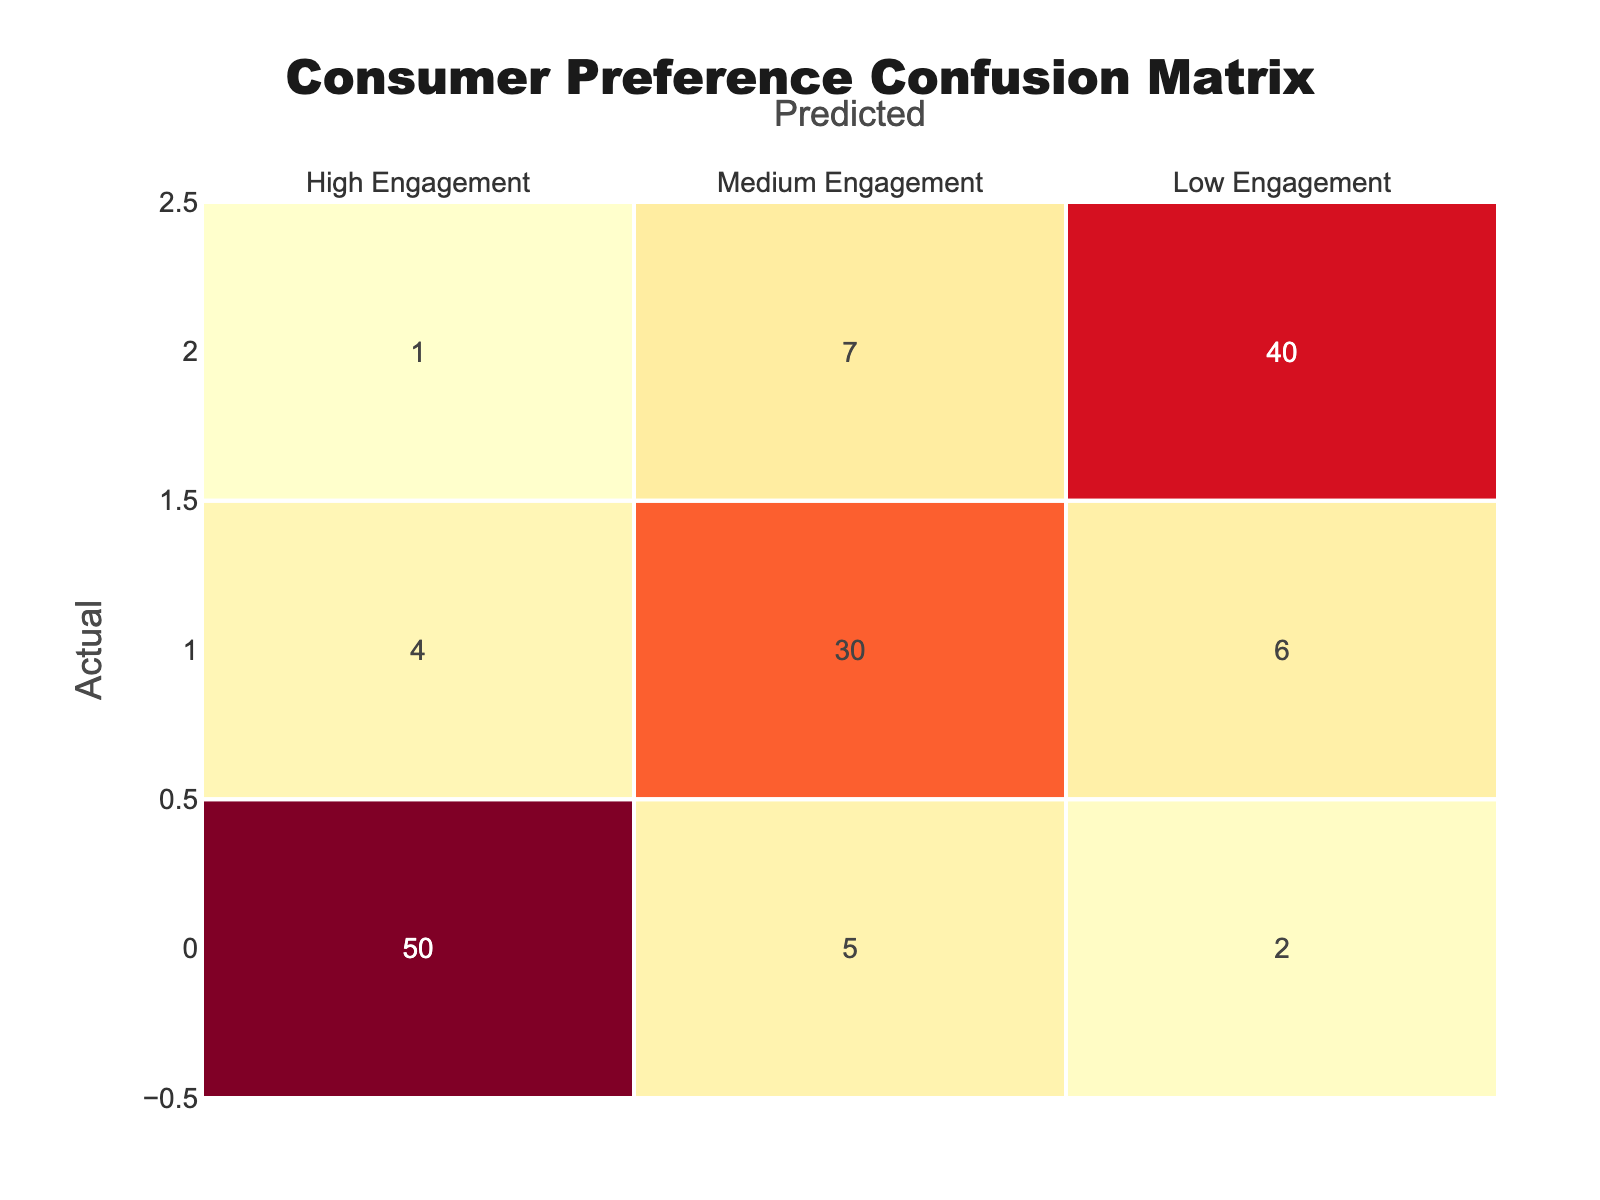What is the count of true positives for high engagement? The true positives for a category are found on the diagonal of the confusion matrix. For high engagement, this is represented in the cell where the actual engagement is high engagement and the predicted engagement is also high engagement. Referring to the table, the count is 50.
Answer: 50 What is the total count of medium engagement predictions? To find the total count of medium engagement predictions, add the predictions from the medium engagement row: 4 (low engagement predicted as medium) + 30 (medium engagement predicted as medium) + 6 (high engagement predicted as medium) = 40.
Answer: 40 Is there more misclassification in the low engagement category than in the high engagement category? Misclassification for each category is calculated by summing the off-diagonal values. For low engagement, the misclassifications are 1 (predicted high) + 7 (predicted medium) = 8. For high engagement, the misclassifications are 5 (predicted medium) + 2 (predicted low) = 7. Since 8 is greater than 7, the statement is true.
Answer: Yes What is the overall accuracy of the predictions? To calculate overall accuracy, we use the formula: (True Positives) / (Total Predictions). Here, the true positives are the sum of the diagonal elements (50 + 30 + 40 = 120). The total predictions are the sum of all elements in the table (50 + 5 + 2 + 4 + 30 + 6 + 1 + 7 + 40 = 145). Accuracy = 120 / 145 ≈ 0.827.
Answer: Approximately 0.827 What is the percentage of high engagement that was correctly predicted? To find the percentage of high engagement that was correctly predicted, divide the true positives for high engagement (50) by the total actual high engagement cases (50 + 5 + 2 = 57). Calculate the percentage: (50 / 57) * 100 ≈ 87.72%.
Answer: Approximately 87.72% What is the difference in the number of misclassifications between medium engagement and low engagement? First, calculate misclassifications for medium engagement: 4 (predicted high) + 6 (predicted low) = 10. For low engagement, misclassifications are 1 (predicted high) + 7 (predicted medium) = 8. The difference is 10 - 8 = 2.
Answer: 2 Which engagement level has the highest true positive count? By examining the diagonal, the counts are 50 for high engagement, 30 for medium engagement, and 40 for low engagement. Since 50 is greater than both 30 and 40, high engagement has the highest true positive count.
Answer: High engagement What proportion of low engagement cases were correctly predicted? The correct predictions for low engagement are represented by the true positives, which is 40. The total actual low engagement cases are 1 (predicted high) + 7 (predicted medium) + 40 = 48. Thus, the proportion is 40 / 48 = 0.833.
Answer: 0.833 